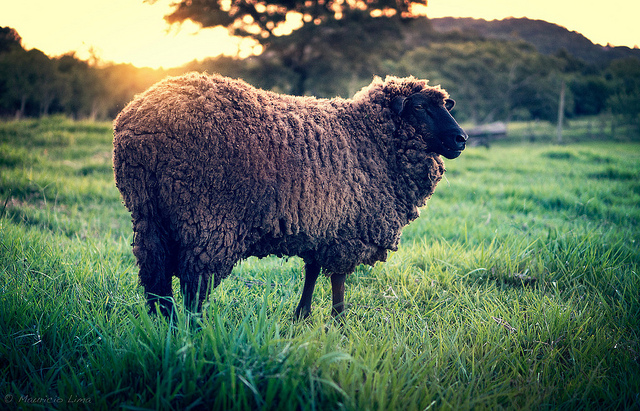What memories might the sheep have of this field if it has lived here all its life? The sheep might remember frolicking as a lamb in the tall, green grass, following its mother and learning to find the juiciest patches of clover. It would recall the warm days under the sun, the cool evenings beneath the trees, and the gentle hum of insects. Every corner of the field would hold a memory—be it from playful chases with fellow sheep or the serene moments of rest under the vast, open sky.  What has the sheep seen and experienced in this field? The sheep has seen the changing seasons, from lush green springs to crisp autumn days. It's felt the refreshing summer rains and the stillness of early morning frost. The sheep has experienced the birth of new lambs, grazing with its flock, and the watchful eyes of its shepherd. It has tasted the sweet nectar of the clover and the tangy flavor of the tall grasses. In this field, the sheep has lived a life marked by the simple yet profound rhythms of nature. 